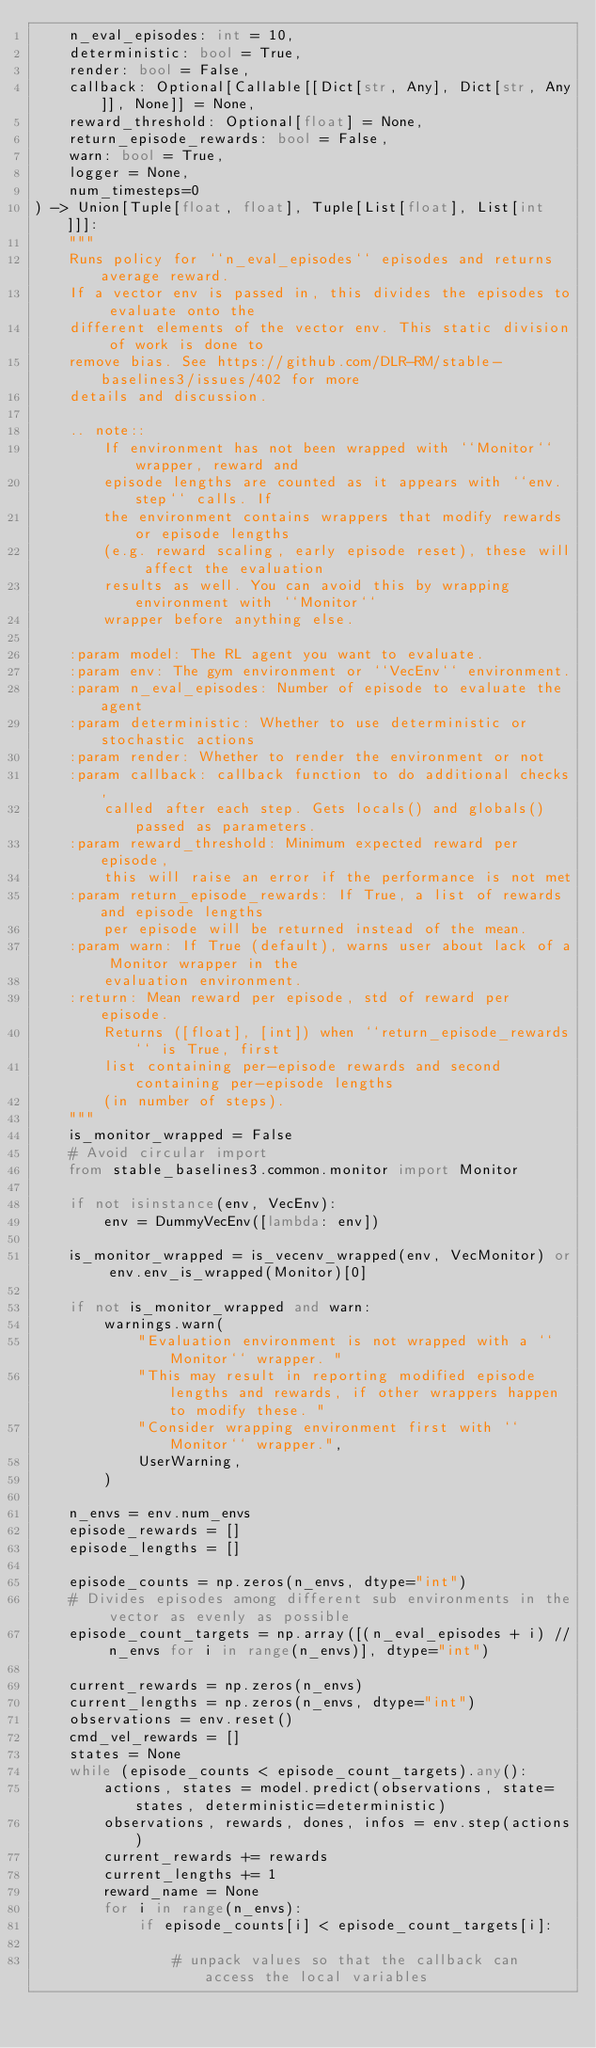Convert code to text. <code><loc_0><loc_0><loc_500><loc_500><_Python_>    n_eval_episodes: int = 10,
    deterministic: bool = True,
    render: bool = False,
    callback: Optional[Callable[[Dict[str, Any], Dict[str, Any]], None]] = None,
    reward_threshold: Optional[float] = None,
    return_episode_rewards: bool = False,
    warn: bool = True,
    logger = None,
    num_timesteps=0
) -> Union[Tuple[float, float], Tuple[List[float], List[int]]]:
    """
    Runs policy for ``n_eval_episodes`` episodes and returns average reward.
    If a vector env is passed in, this divides the episodes to evaluate onto the
    different elements of the vector env. This static division of work is done to
    remove bias. See https://github.com/DLR-RM/stable-baselines3/issues/402 for more
    details and discussion.

    .. note::
        If environment has not been wrapped with ``Monitor`` wrapper, reward and
        episode lengths are counted as it appears with ``env.step`` calls. If
        the environment contains wrappers that modify rewards or episode lengths
        (e.g. reward scaling, early episode reset), these will affect the evaluation
        results as well. You can avoid this by wrapping environment with ``Monitor``
        wrapper before anything else.

    :param model: The RL agent you want to evaluate.
    :param env: The gym environment or ``VecEnv`` environment.
    :param n_eval_episodes: Number of episode to evaluate the agent
    :param deterministic: Whether to use deterministic or stochastic actions
    :param render: Whether to render the environment or not
    :param callback: callback function to do additional checks,
        called after each step. Gets locals() and globals() passed as parameters.
    :param reward_threshold: Minimum expected reward per episode,
        this will raise an error if the performance is not met
    :param return_episode_rewards: If True, a list of rewards and episode lengths
        per episode will be returned instead of the mean.
    :param warn: If True (default), warns user about lack of a Monitor wrapper in the
        evaluation environment.
    :return: Mean reward per episode, std of reward per episode.
        Returns ([float], [int]) when ``return_episode_rewards`` is True, first
        list containing per-episode rewards and second containing per-episode lengths
        (in number of steps).
    """
    is_monitor_wrapped = False
    # Avoid circular import
    from stable_baselines3.common.monitor import Monitor

    if not isinstance(env, VecEnv):
        env = DummyVecEnv([lambda: env])

    is_monitor_wrapped = is_vecenv_wrapped(env, VecMonitor) or env.env_is_wrapped(Monitor)[0]

    if not is_monitor_wrapped and warn:
        warnings.warn(
            "Evaluation environment is not wrapped with a ``Monitor`` wrapper. "
            "This may result in reporting modified episode lengths and rewards, if other wrappers happen to modify these. "
            "Consider wrapping environment first with ``Monitor`` wrapper.",
            UserWarning,
        )

    n_envs = env.num_envs
    episode_rewards = []
    episode_lengths = []

    episode_counts = np.zeros(n_envs, dtype="int")
    # Divides episodes among different sub environments in the vector as evenly as possible
    episode_count_targets = np.array([(n_eval_episodes + i) // n_envs for i in range(n_envs)], dtype="int")

    current_rewards = np.zeros(n_envs)
    current_lengths = np.zeros(n_envs, dtype="int")
    observations = env.reset()
    cmd_vel_rewards = []
    states = None
    while (episode_counts < episode_count_targets).any():
        actions, states = model.predict(observations, state=states, deterministic=deterministic)
        observations, rewards, dones, infos = env.step(actions)
        current_rewards += rewards
        current_lengths += 1
        reward_name = None
        for i in range(n_envs):
            if episode_counts[i] < episode_count_targets[i]:

                # unpack values so that the callback can access the local variables</code> 